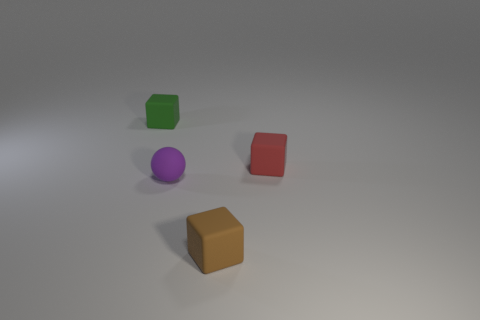Add 2 big spheres. How many objects exist? 6 Subtract all cubes. How many objects are left? 1 Add 3 green rubber things. How many green rubber things are left? 4 Add 3 tiny rubber things. How many tiny rubber things exist? 7 Subtract 1 red blocks. How many objects are left? 3 Subtract all tiny blue balls. Subtract all small red rubber objects. How many objects are left? 3 